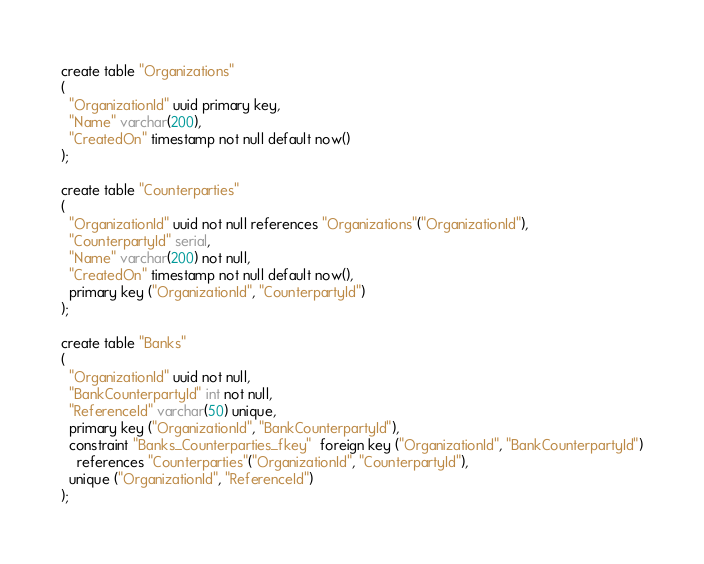<code> <loc_0><loc_0><loc_500><loc_500><_SQL_>create table "Organizations"
(
  "OrganizationId" uuid primary key,
  "Name" varchar(200),
  "CreatedOn" timestamp not null default now()
);

create table "Counterparties"
(
  "OrganizationId" uuid not null references "Organizations"("OrganizationId"),
  "CounterpartyId" serial,
  "Name" varchar(200) not null,
  "CreatedOn" timestamp not null default now(),
  primary key ("OrganizationId", "CounterpartyId")
);

create table "Banks"
(
  "OrganizationId" uuid not null,
  "BankCounterpartyId" int not null,
  "ReferenceId" varchar(50) unique,
  primary key ("OrganizationId", "BankCounterpartyId"),
  constraint "Banks_Counterparties_fkey"  foreign key ("OrganizationId", "BankCounterpartyId")
    references "Counterparties"("OrganizationId", "CounterpartyId"),
  unique ("OrganizationId", "ReferenceId")
);
</code> 